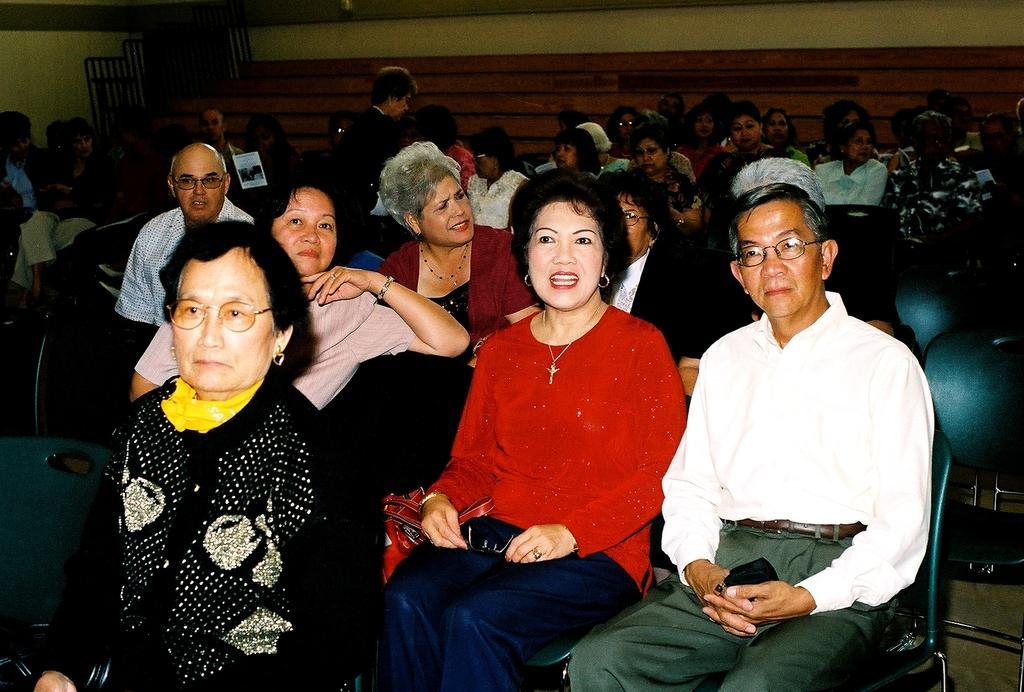Could you give a brief overview of what you see in this image? There are many people sitting on the chairs. Some are wearing specs. In the back there is a wall. 